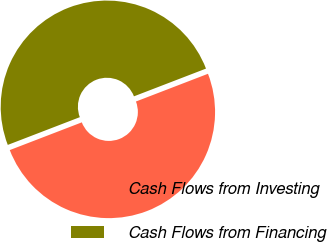Convert chart to OTSL. <chart><loc_0><loc_0><loc_500><loc_500><pie_chart><fcel>Cash Flows from Investing<fcel>Cash Flows from Financing<nl><fcel>50.0%<fcel>50.0%<nl></chart> 